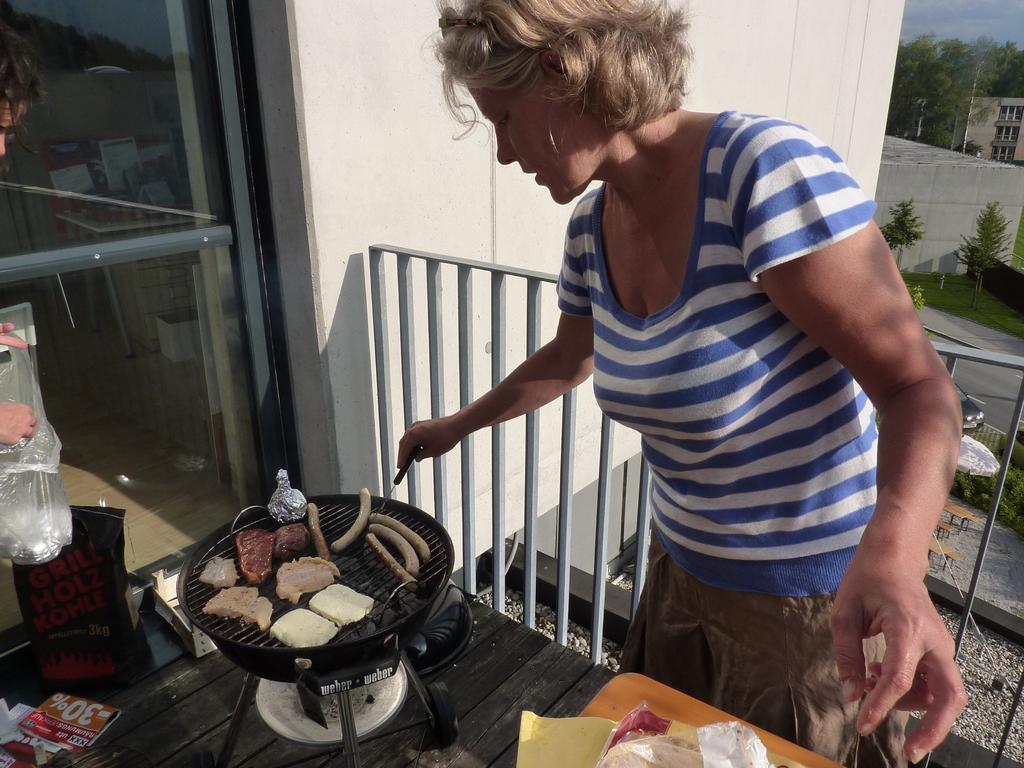What is the kind of coal?
Keep it short and to the point. Charcoal. What percent is advertised on small red paper?
Make the answer very short. 30. 